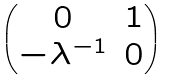<formula> <loc_0><loc_0><loc_500><loc_500>\begin{pmatrix} 0 & 1 \\ - \lambda ^ { - 1 } & 0 \end{pmatrix}</formula> 